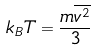<formula> <loc_0><loc_0><loc_500><loc_500>k _ { B } T = \frac { m \overline { v ^ { 2 } } } { 3 }</formula> 